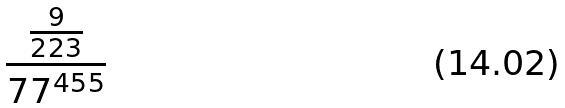Convert formula to latex. <formula><loc_0><loc_0><loc_500><loc_500>\frac { \frac { 9 } { 2 2 3 } } { 7 7 ^ { 4 5 5 } }</formula> 